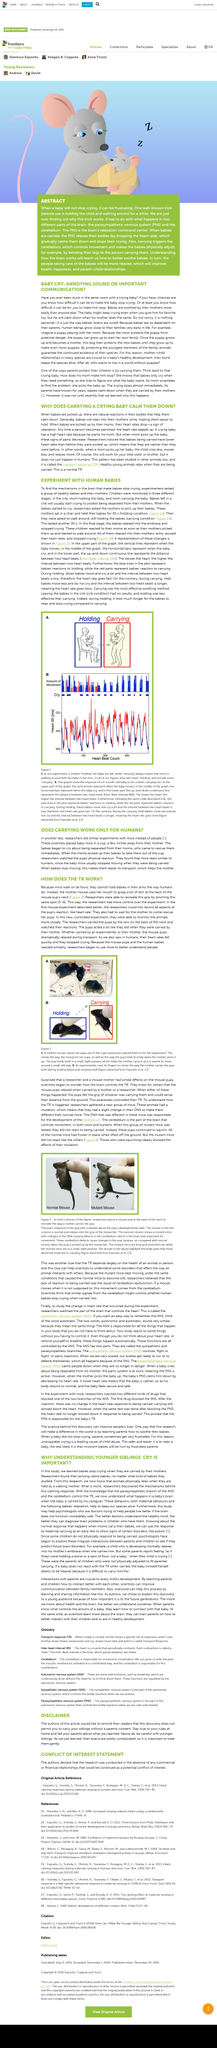Give some essential details in this illustration. It is important to exercise caution when interacting with younger siblings, as they may not fully comprehend the potential consequences of their actions. A team of scientists conducted an experiment on mice to determine the effectiveness of a new treatment for a particular disease. The fact that baby mice are easier to carry when they stop moving makes them more manageable and less likely to escape. When baby mice are carried, they stop moving as a result. 